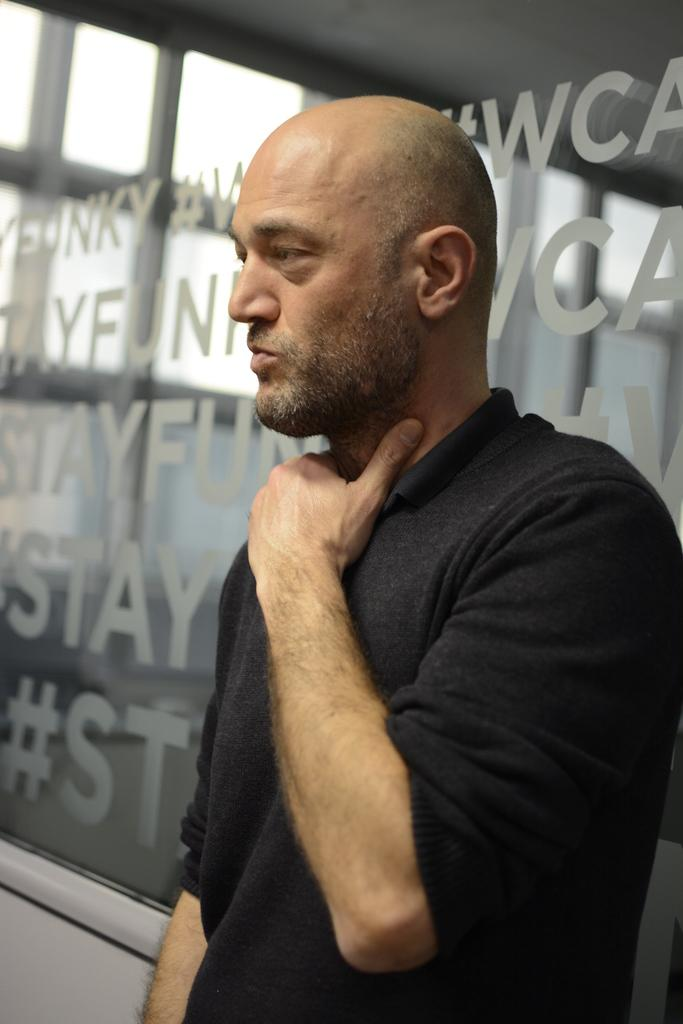What is the main subject of the image? There is a person standing in the center of the image. Can you describe the person's clothing? The person is wearing a black t-shirt. What can be seen in the background of the image? There is a wall, a roof, and glass in the background of the image. What is written or displayed on the glass? There is text on the glass. What type of string is being used to hold the jelly in the image? There is no string or jelly present in the image. How does the sail affect the person's position in the image? There is no sail present in the image, so it does not affect the person's position. 